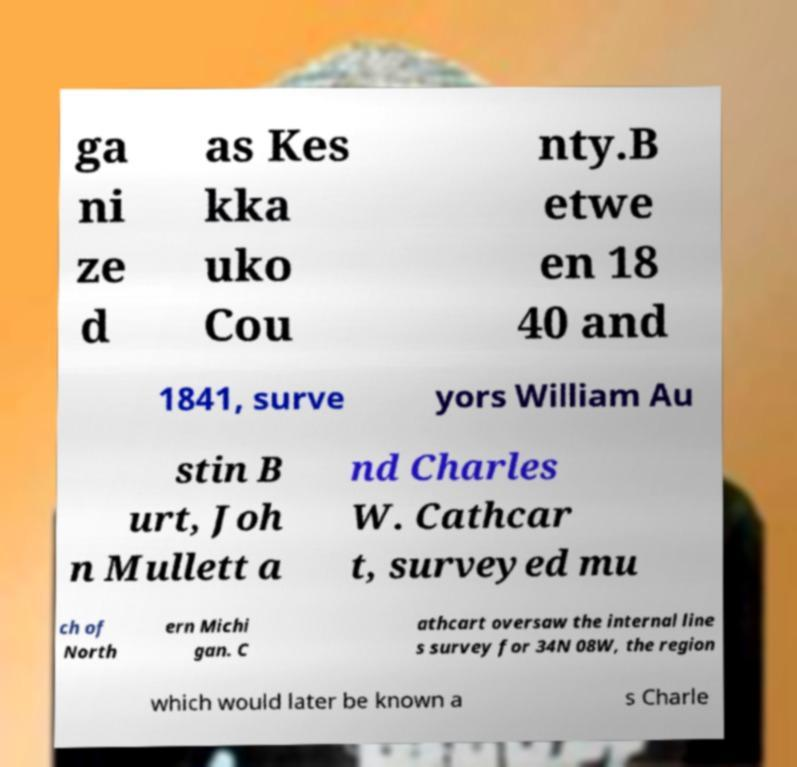Please read and relay the text visible in this image. What does it say? ga ni ze d as Kes kka uko Cou nty.B etwe en 18 40 and 1841, surve yors William Au stin B urt, Joh n Mullett a nd Charles W. Cathcar t, surveyed mu ch of North ern Michi gan. C athcart oversaw the internal line s survey for 34N 08W, the region which would later be known a s Charle 